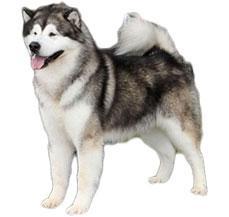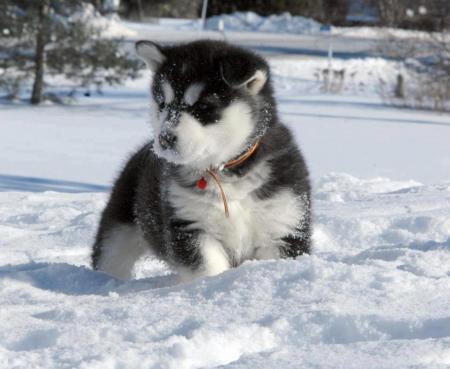The first image is the image on the left, the second image is the image on the right. Analyze the images presented: Is the assertion "All dogs are in snowy scenes, and the left image features a reclining black-and-white husky, while the right image features an upright husky." valid? Answer yes or no. No. 